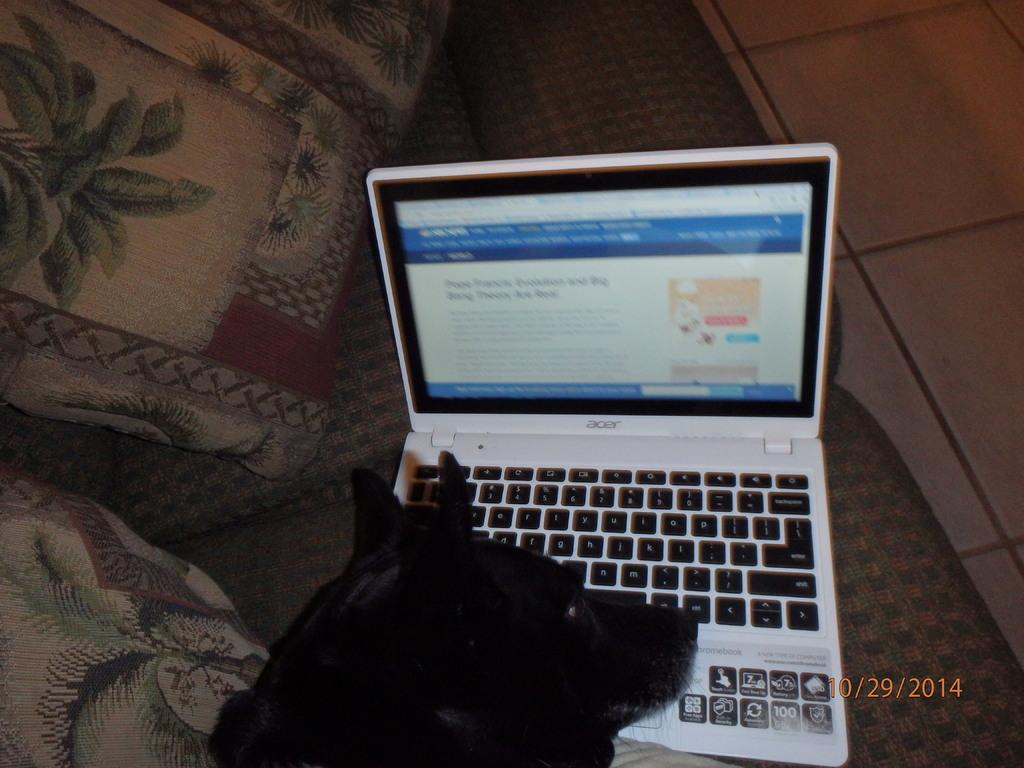Provide a one-sentence caption for the provided image. a black dog in front of a lap top computer taken on 10/29/2014. 